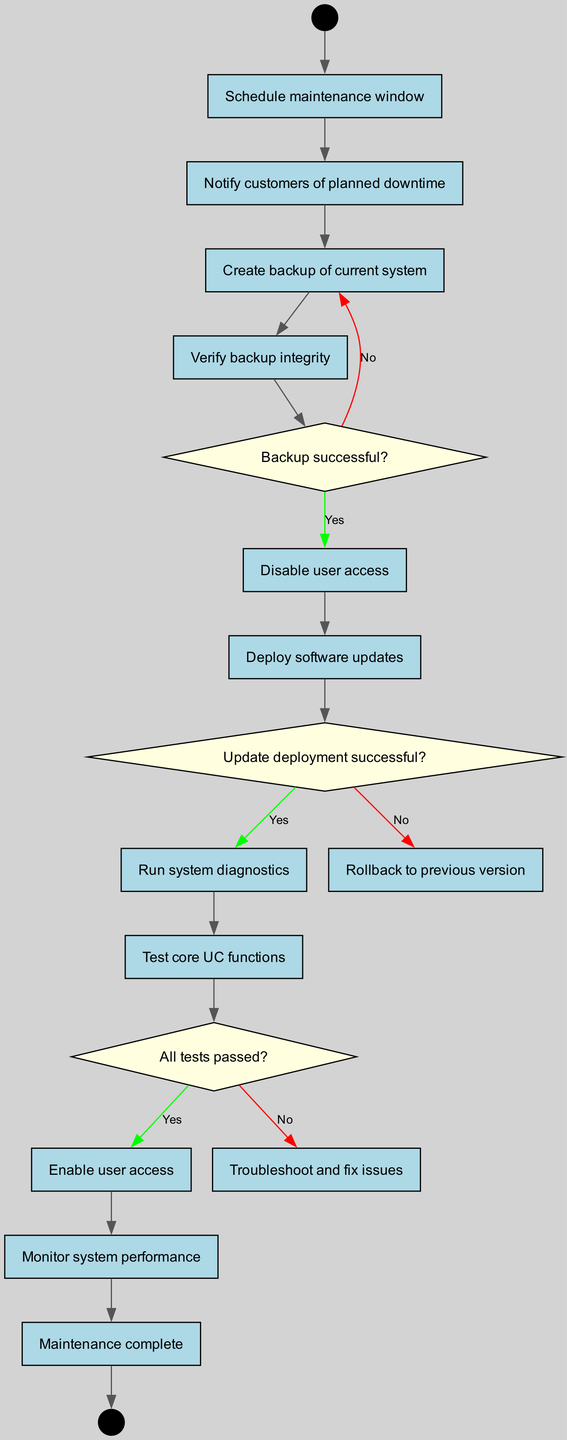What is the first activity in the maintenance procedure? The first activity is to "Notify customers of planned downtime," which directly follows the initial node "Schedule maintenance window."
Answer: Notify customers of planned downtime How many decision nodes are present in the diagram? There are three decision nodes in the diagram, each introducing a condition that affects the flow based on its answer.
Answer: 3 What happens if the backup is not successful? If the backup is not successful, the procedure goes back to "Create backup of current system," according to the flow from the decision node for backup success.
Answer: Create backup of current system What activity follows after "Run system diagnostics"? After "Run system diagnostics," the next activity is "Test core UC functions," indicating that diagnostics must be followed by testing to ensure functionality.
Answer: Test core UC functions If "Update deployment successful?" is answered with "No", what is the next action taken? If the answer is "No" to "Update deployment successful?", the diagram specifies that the next action is to "Rollback to previous version," reverting any changes made during the update.
Answer: Rollback to previous version What is the final node in the maintenance process? The final node in the maintenance process is "Maintenance complete," which signifies the end of the entire procedure.
Answer: Maintenance complete What activity occurs immediately after "Enable user access"? The activity that occurs immediately after "Enable user access" is "Monitor system performance," indicating that once access is granted, monitoring begins.
Answer: Monitor system performance What is verified after creating a backup? After creating a backup, the next step is to "Verify backup integrity," ensuring that the backup is reliable and usable if needed.
Answer: Verify backup integrity What happens if "All tests passed?" If "All tests passed?" is answered with "Yes," the procedure continues to "Enable user access," allowing users to access the system once testing is validated.
Answer: Enable user access 